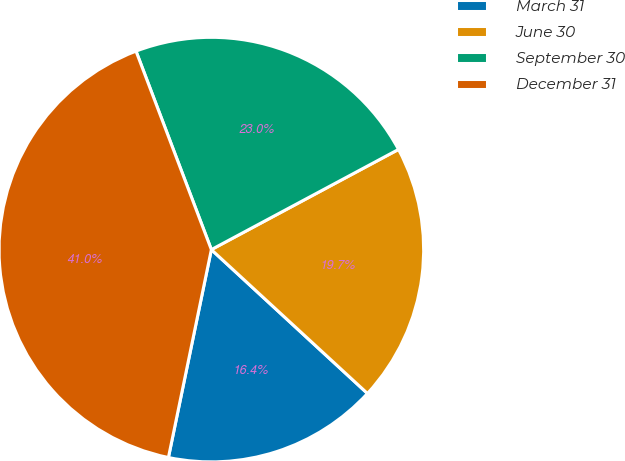Convert chart. <chart><loc_0><loc_0><loc_500><loc_500><pie_chart><fcel>March 31<fcel>June 30<fcel>September 30<fcel>December 31<nl><fcel>16.39%<fcel>19.67%<fcel>22.95%<fcel>40.98%<nl></chart> 